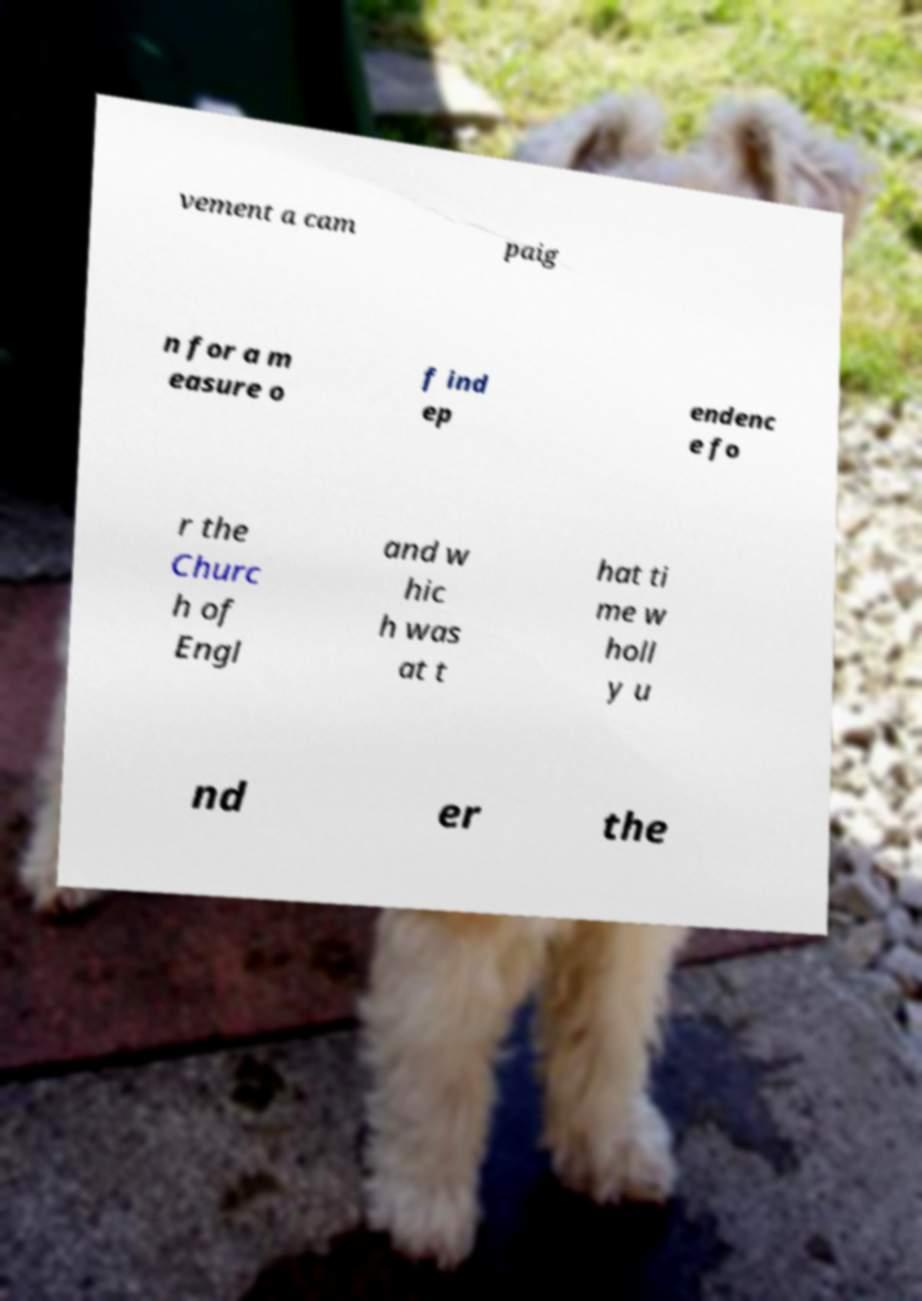For documentation purposes, I need the text within this image transcribed. Could you provide that? vement a cam paig n for a m easure o f ind ep endenc e fo r the Churc h of Engl and w hic h was at t hat ti me w holl y u nd er the 